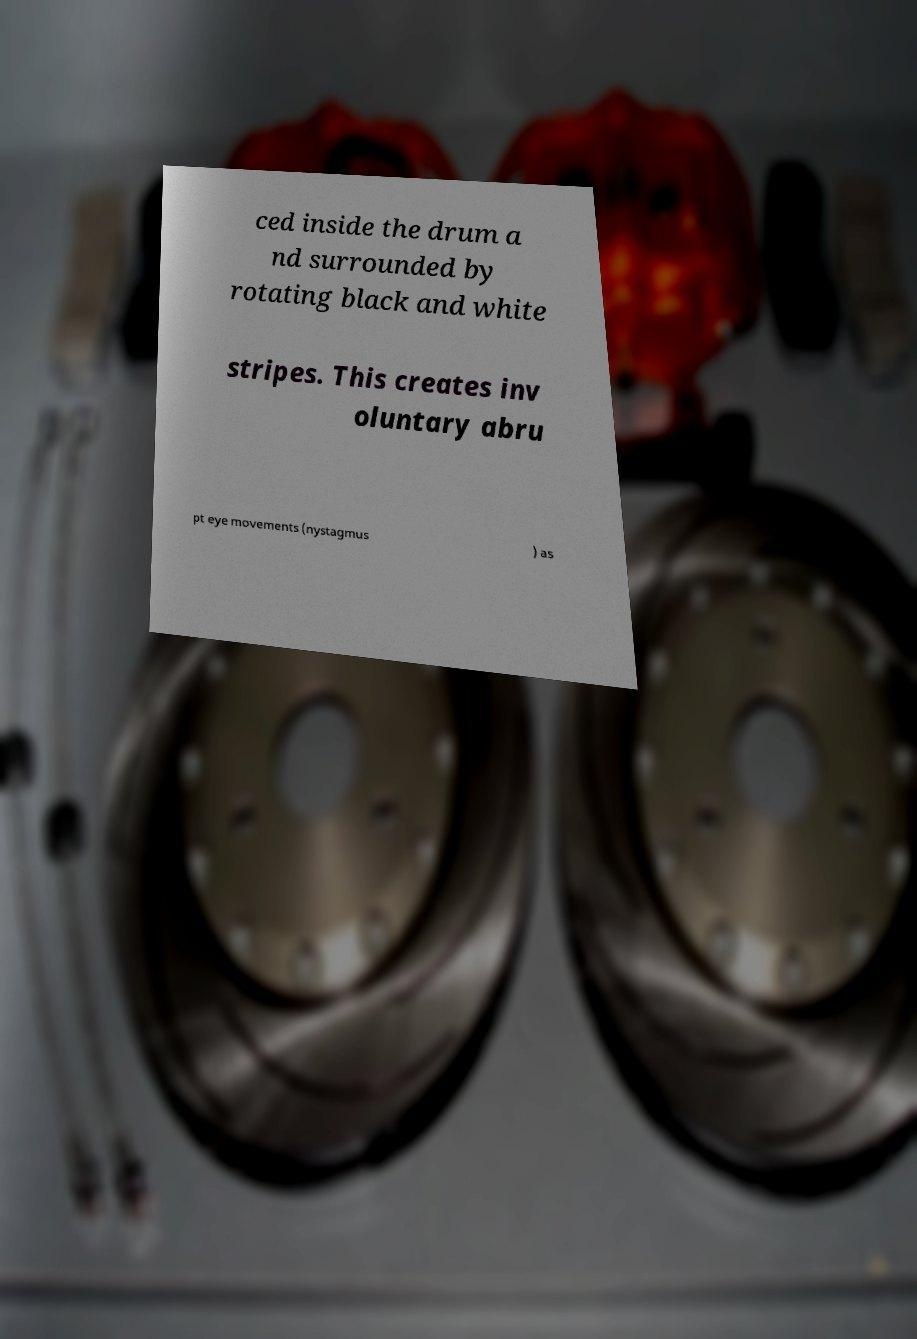Can you read and provide the text displayed in the image?This photo seems to have some interesting text. Can you extract and type it out for me? ced inside the drum a nd surrounded by rotating black and white stripes. This creates inv oluntary abru pt eye movements (nystagmus ) as 